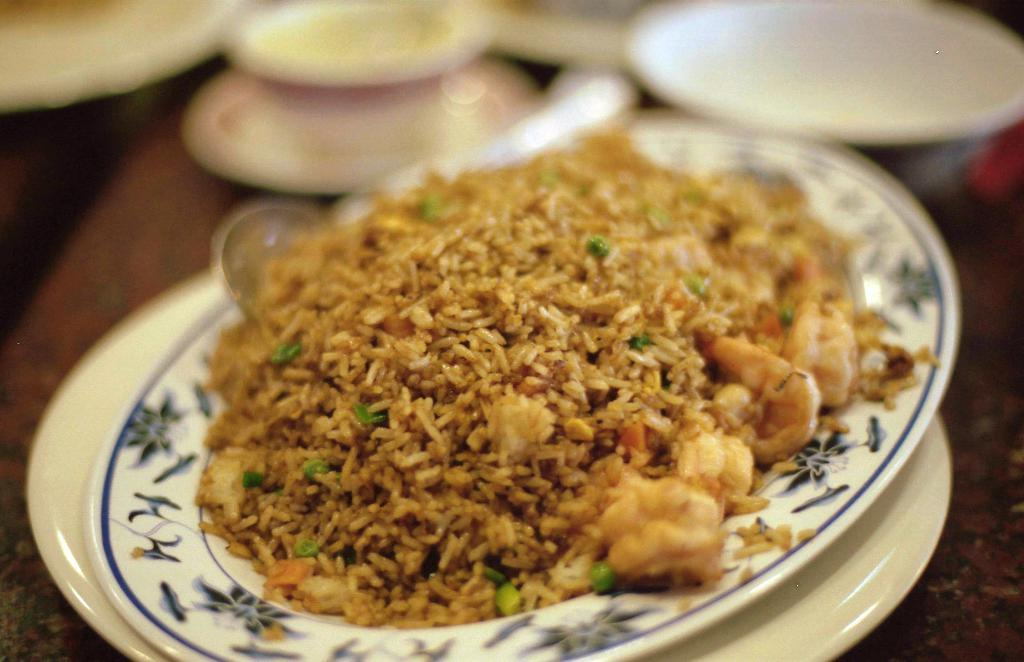What type of furniture is present in the image? There is a table in the image. What is placed on the table in the image? There is a serving plate on the table. What can be found on the serving plate? There is food on the serving plate. How many sisters are sitting at the table in the image? There is no mention of sisters in the image; it only features a table, a serving plate, and food on the plate. What type of bears can be seen interacting with the food on the serving plate? There are no bears present in the image. 